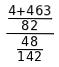<formula> <loc_0><loc_0><loc_500><loc_500>\frac { \frac { 4 + 4 6 3 } { 8 2 } } { \frac { 4 8 } { 1 4 2 } }</formula> 